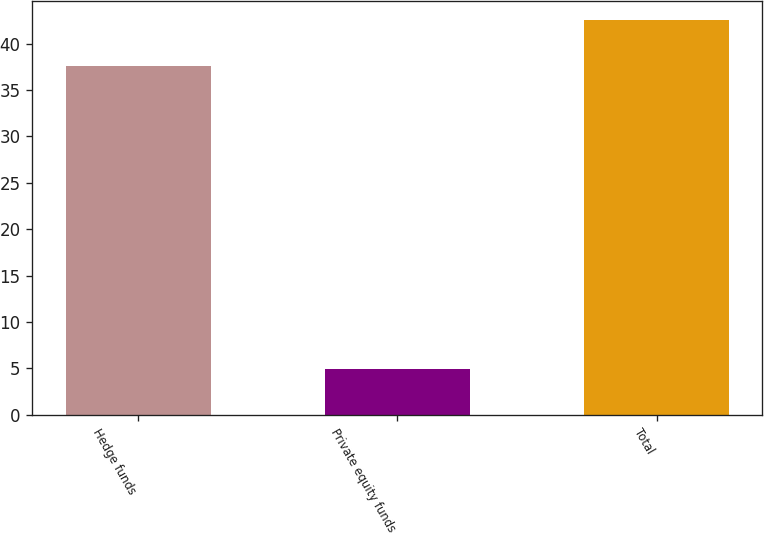Convert chart. <chart><loc_0><loc_0><loc_500><loc_500><bar_chart><fcel>Hedge funds<fcel>Private equity funds<fcel>Total<nl><fcel>37.6<fcel>4.9<fcel>42.5<nl></chart> 